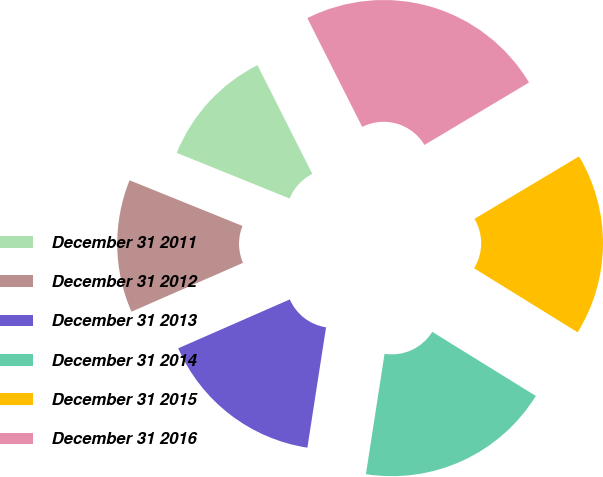Convert chart to OTSL. <chart><loc_0><loc_0><loc_500><loc_500><pie_chart><fcel>December 31 2011<fcel>December 31 2012<fcel>December 31 2013<fcel>December 31 2014<fcel>December 31 2015<fcel>December 31 2016<nl><fcel>11.45%<fcel>12.69%<fcel>15.98%<fcel>18.63%<fcel>17.39%<fcel>23.87%<nl></chart> 